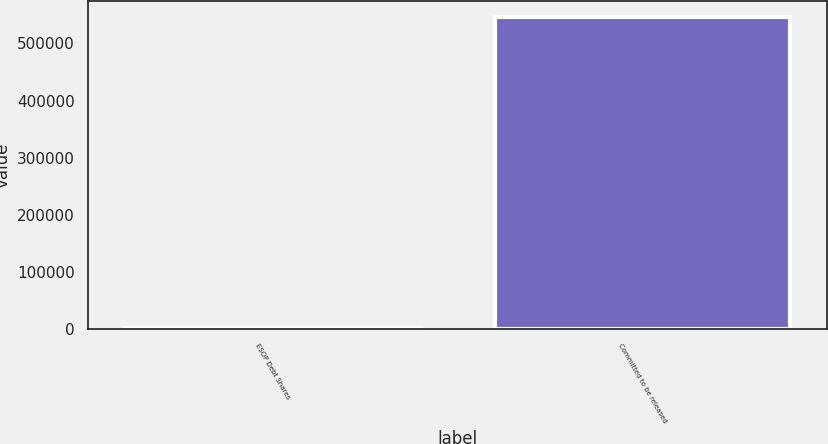Convert chart. <chart><loc_0><loc_0><loc_500><loc_500><bar_chart><fcel>ESOP Debt Shares<fcel>Committed to be released<nl><fcel>2003<fcel>546798<nl></chart> 